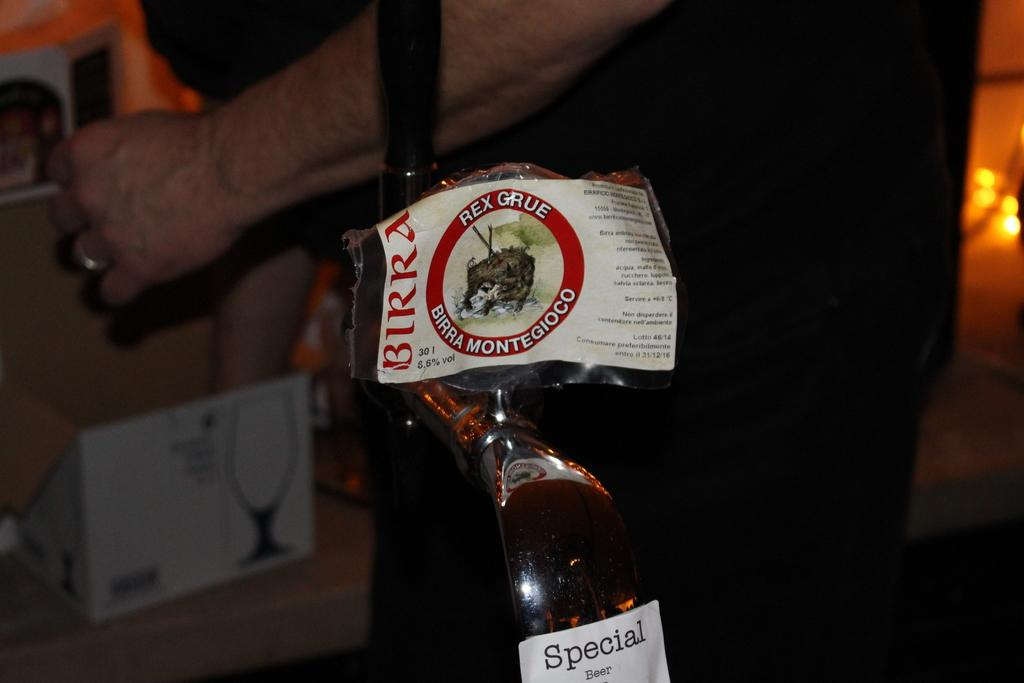<image>
Give a short and clear explanation of the subsequent image. The label from a Birra bottle has been peeled off. 